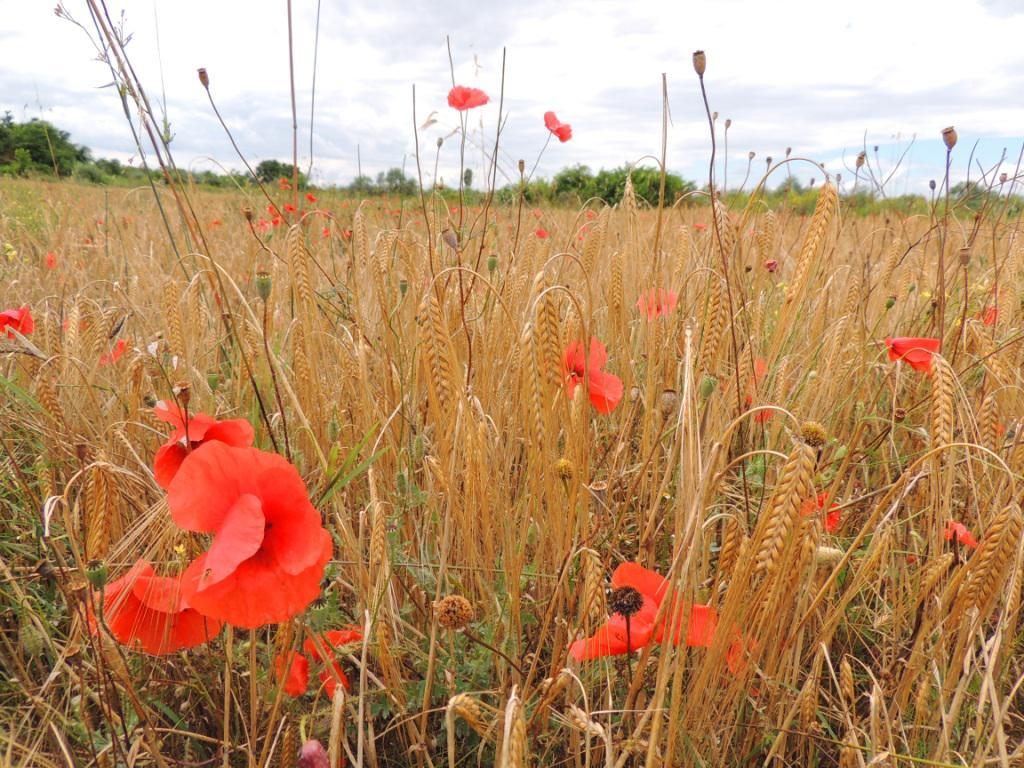What type of plants can be seen in the image? There are plants with flowers in the image. What stage of growth are the plants in? The plants have buds. What can be seen in the background of the image? There are trees visible in the background of the image. What is visible at the top of the image? The sky is visible at the top of the image. What type of glue is being used to hold the car together in the image? There is no car present in the image, so there is no glue or any related activity to discuss. 